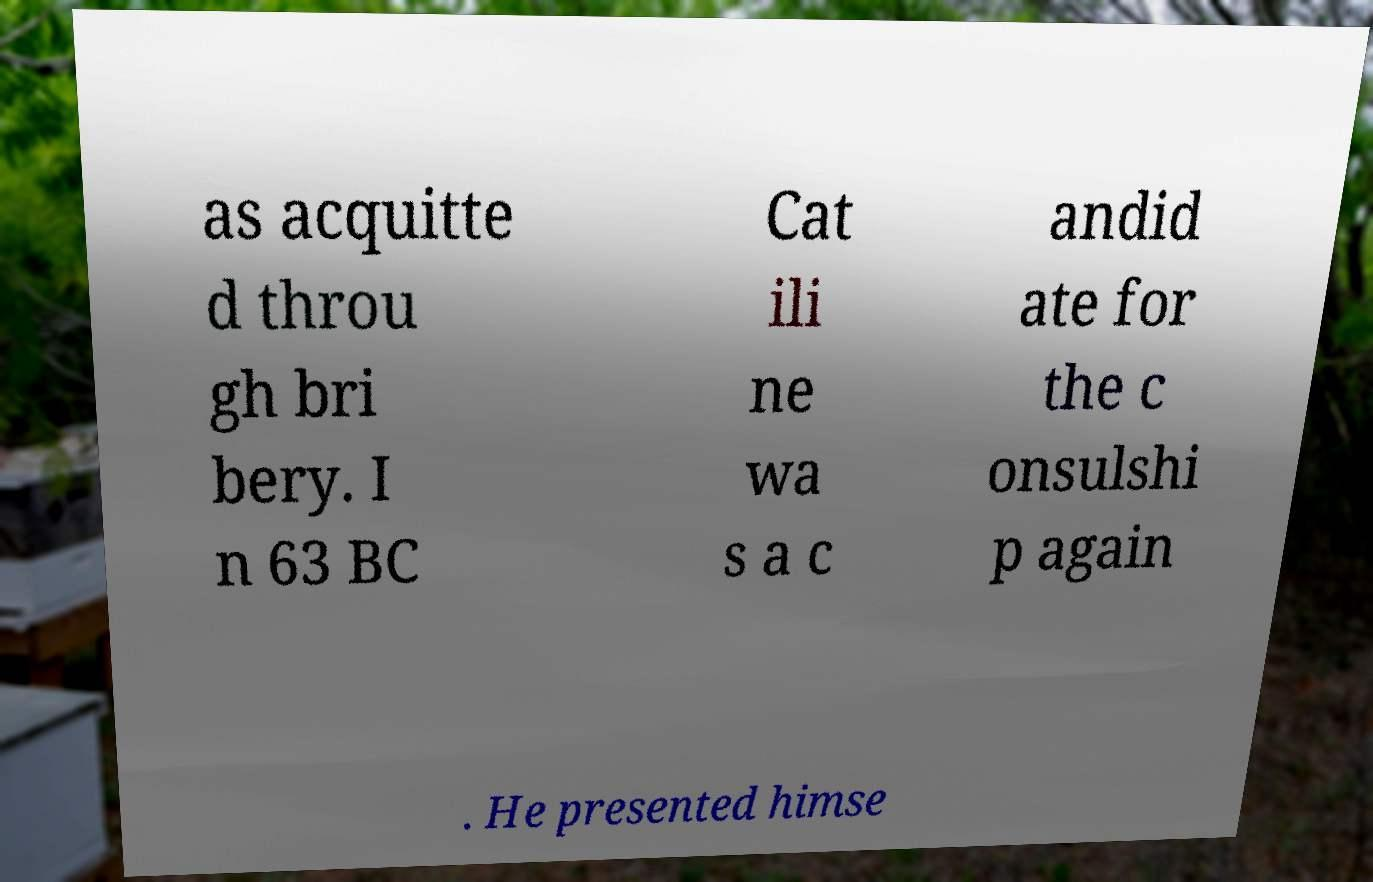Can you read and provide the text displayed in the image?This photo seems to have some interesting text. Can you extract and type it out for me? as acquitte d throu gh bri bery. I n 63 BC Cat ili ne wa s a c andid ate for the c onsulshi p again . He presented himse 